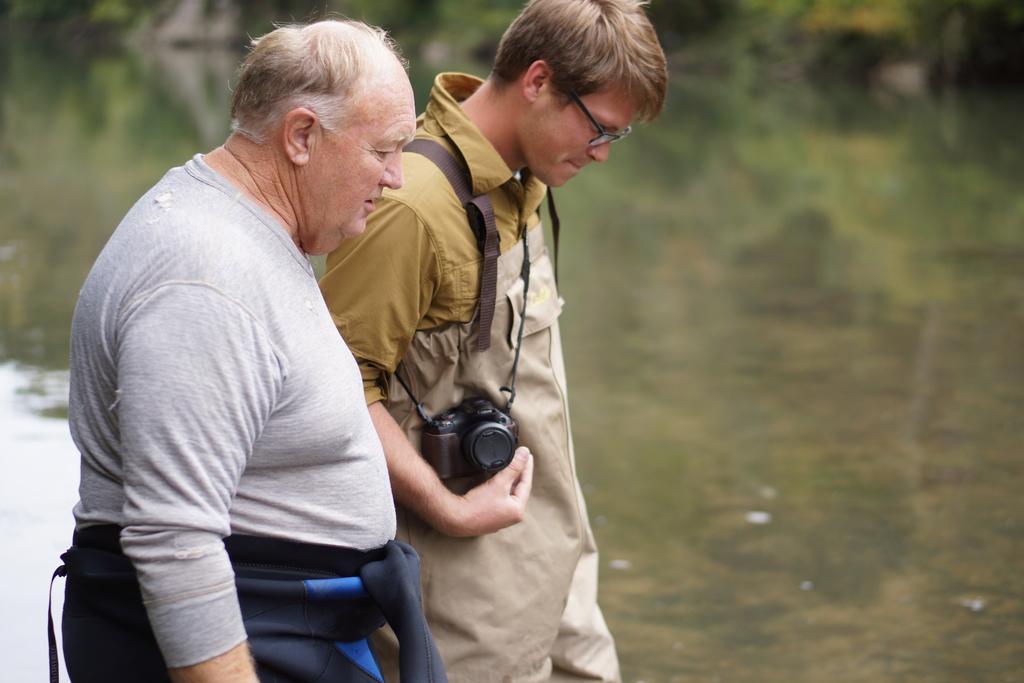Could you give a brief overview of what you see in this image? This image is taken outside of the city where the two persons are taking a walk, this person is holding a camera. In the background there are trees which are blurred. 